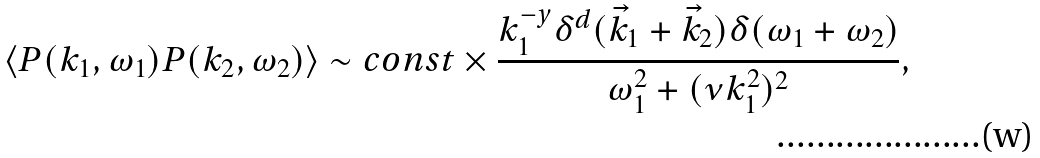<formula> <loc_0><loc_0><loc_500><loc_500>\langle P ( k _ { 1 } , \omega _ { 1 } ) P ( k _ { 2 } , \omega _ { 2 } ) \rangle \sim c o n s t \times \frac { k _ { 1 } ^ { - y } \delta ^ { d } ( { \vec { k } } _ { 1 } + { \vec { k } } _ { 2 } ) \delta ( \omega _ { 1 } + \omega _ { 2 } ) } { \omega _ { 1 } ^ { 2 } + ( \nu k _ { 1 } ^ { 2 } ) ^ { 2 } } ,</formula> 